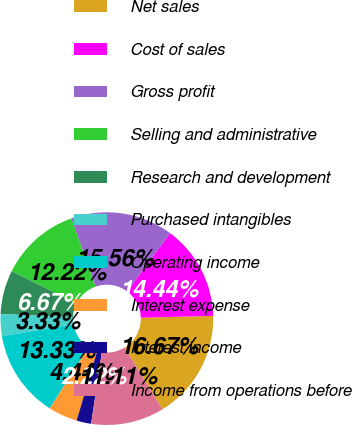<chart> <loc_0><loc_0><loc_500><loc_500><pie_chart><fcel>Net sales<fcel>Cost of sales<fcel>Gross profit<fcel>Selling and administrative<fcel>Research and development<fcel>Purchased intangibles<fcel>Operating income<fcel>Interest expense<fcel>Interest income<fcel>Income from operations before<nl><fcel>16.67%<fcel>14.44%<fcel>15.56%<fcel>12.22%<fcel>6.67%<fcel>3.33%<fcel>13.33%<fcel>4.44%<fcel>2.22%<fcel>11.11%<nl></chart> 